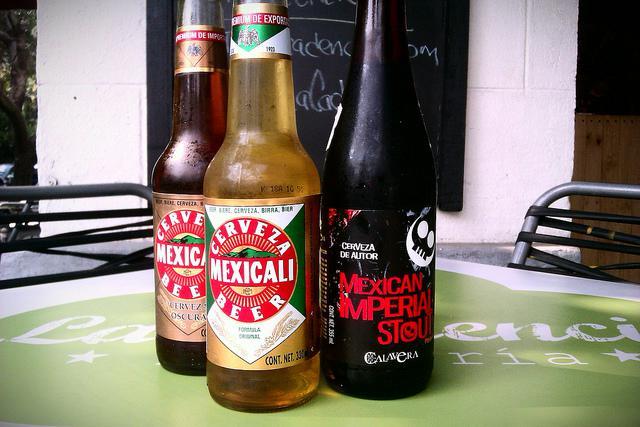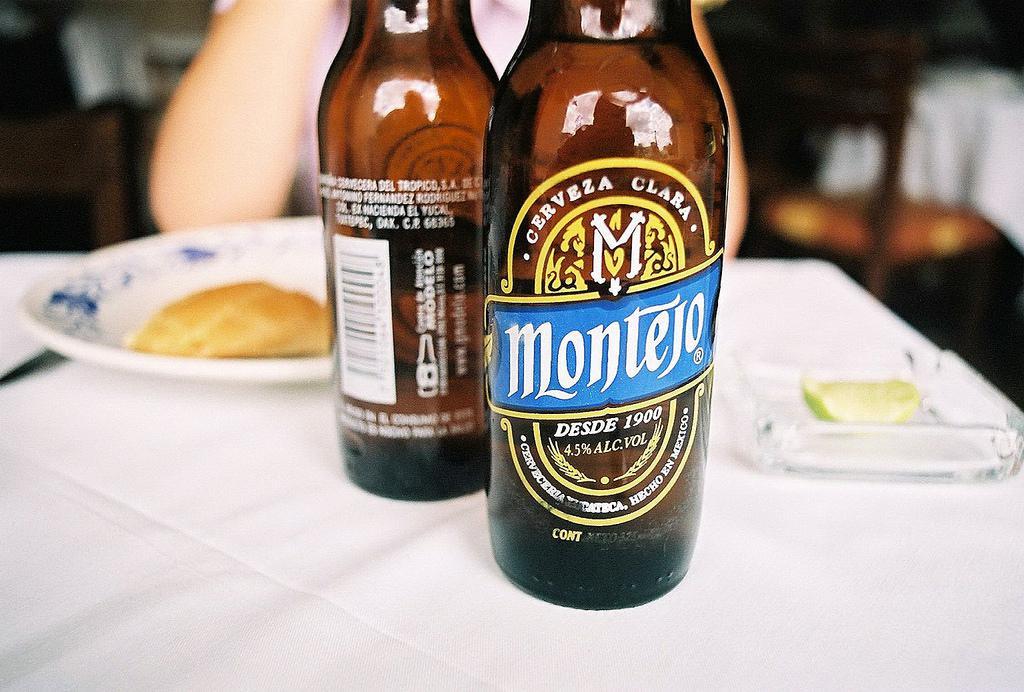The first image is the image on the left, the second image is the image on the right. Evaluate the accuracy of this statement regarding the images: "One image contains exactly two brown glass beer bottles standing on a table, and no image contains more than three glass bottles.". Is it true? Answer yes or no. Yes. The first image is the image on the left, the second image is the image on the right. Given the left and right images, does the statement "There are exactly two bottles in one of the images." hold true? Answer yes or no. Yes. 